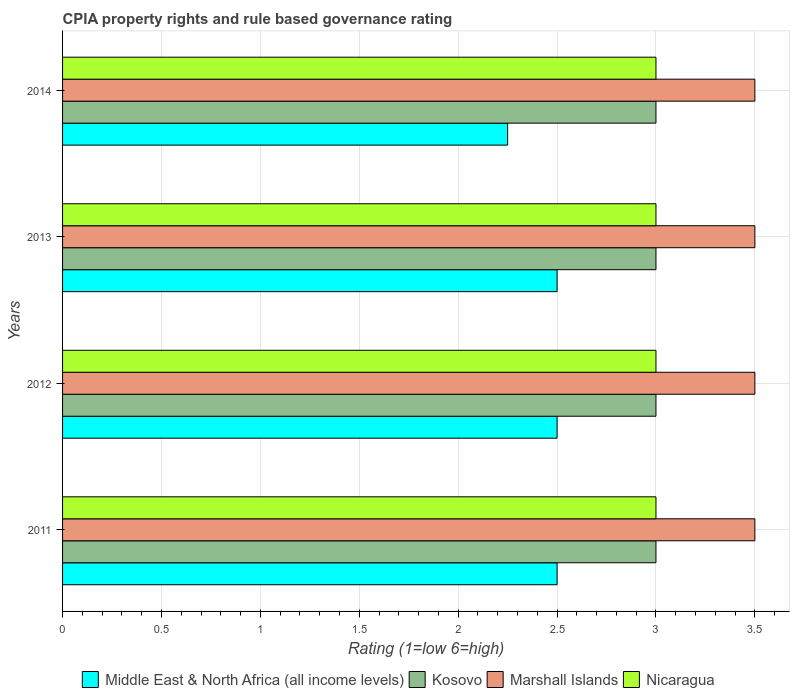How many bars are there on the 3rd tick from the bottom?
Provide a short and direct response. 4. What is the label of the 4th group of bars from the top?
Provide a succinct answer. 2011. Across all years, what is the maximum CPIA rating in Nicaragua?
Provide a succinct answer. 3. Across all years, what is the minimum CPIA rating in Kosovo?
Offer a terse response. 3. In which year was the CPIA rating in Nicaragua maximum?
Ensure brevity in your answer.  2011. In which year was the CPIA rating in Nicaragua minimum?
Offer a terse response. 2011. What is the total CPIA rating in Marshall Islands in the graph?
Give a very brief answer. 14. What is the difference between the CPIA rating in Nicaragua in 2012 and that in 2014?
Your answer should be very brief. 0. What is the average CPIA rating in Nicaragua per year?
Ensure brevity in your answer.  3. In the year 2012, what is the difference between the CPIA rating in Marshall Islands and CPIA rating in Nicaragua?
Provide a succinct answer. 0.5. What is the difference between the highest and the lowest CPIA rating in Nicaragua?
Provide a succinct answer. 0. Is the sum of the CPIA rating in Nicaragua in 2011 and 2012 greater than the maximum CPIA rating in Marshall Islands across all years?
Provide a short and direct response. Yes. Is it the case that in every year, the sum of the CPIA rating in Marshall Islands and CPIA rating in Middle East & North Africa (all income levels) is greater than the sum of CPIA rating in Nicaragua and CPIA rating in Kosovo?
Provide a succinct answer. No. What does the 4th bar from the top in 2013 represents?
Your answer should be very brief. Middle East & North Africa (all income levels). What does the 2nd bar from the bottom in 2011 represents?
Make the answer very short. Kosovo. Is it the case that in every year, the sum of the CPIA rating in Nicaragua and CPIA rating in Marshall Islands is greater than the CPIA rating in Middle East & North Africa (all income levels)?
Your answer should be very brief. Yes. What is the difference between two consecutive major ticks on the X-axis?
Give a very brief answer. 0.5. Are the values on the major ticks of X-axis written in scientific E-notation?
Your response must be concise. No. Does the graph contain any zero values?
Your answer should be very brief. No. How many legend labels are there?
Make the answer very short. 4. What is the title of the graph?
Keep it short and to the point. CPIA property rights and rule based governance rating. Does "Jordan" appear as one of the legend labels in the graph?
Your response must be concise. No. What is the Rating (1=low 6=high) of Middle East & North Africa (all income levels) in 2012?
Make the answer very short. 2.5. What is the Rating (1=low 6=high) in Kosovo in 2012?
Keep it short and to the point. 3. What is the Rating (1=low 6=high) of Nicaragua in 2013?
Keep it short and to the point. 3. What is the Rating (1=low 6=high) of Middle East & North Africa (all income levels) in 2014?
Give a very brief answer. 2.25. What is the Rating (1=low 6=high) of Kosovo in 2014?
Your response must be concise. 3. What is the Rating (1=low 6=high) in Marshall Islands in 2014?
Provide a succinct answer. 3.5. What is the Rating (1=low 6=high) of Nicaragua in 2014?
Your answer should be very brief. 3. Across all years, what is the maximum Rating (1=low 6=high) in Middle East & North Africa (all income levels)?
Offer a terse response. 2.5. Across all years, what is the maximum Rating (1=low 6=high) of Kosovo?
Keep it short and to the point. 3. Across all years, what is the maximum Rating (1=low 6=high) of Nicaragua?
Keep it short and to the point. 3. Across all years, what is the minimum Rating (1=low 6=high) in Middle East & North Africa (all income levels)?
Offer a terse response. 2.25. Across all years, what is the minimum Rating (1=low 6=high) of Kosovo?
Your response must be concise. 3. Across all years, what is the minimum Rating (1=low 6=high) in Marshall Islands?
Offer a very short reply. 3.5. Across all years, what is the minimum Rating (1=low 6=high) in Nicaragua?
Your answer should be compact. 3. What is the total Rating (1=low 6=high) of Middle East & North Africa (all income levels) in the graph?
Provide a succinct answer. 9.75. What is the total Rating (1=low 6=high) of Kosovo in the graph?
Give a very brief answer. 12. What is the total Rating (1=low 6=high) in Nicaragua in the graph?
Your answer should be compact. 12. What is the difference between the Rating (1=low 6=high) of Middle East & North Africa (all income levels) in 2011 and that in 2012?
Offer a terse response. 0. What is the difference between the Rating (1=low 6=high) of Kosovo in 2011 and that in 2012?
Your answer should be compact. 0. What is the difference between the Rating (1=low 6=high) in Middle East & North Africa (all income levels) in 2011 and that in 2013?
Keep it short and to the point. 0. What is the difference between the Rating (1=low 6=high) of Marshall Islands in 2011 and that in 2013?
Your answer should be compact. 0. What is the difference between the Rating (1=low 6=high) in Nicaragua in 2011 and that in 2013?
Ensure brevity in your answer.  0. What is the difference between the Rating (1=low 6=high) in Middle East & North Africa (all income levels) in 2011 and that in 2014?
Give a very brief answer. 0.25. What is the difference between the Rating (1=low 6=high) in Kosovo in 2011 and that in 2014?
Make the answer very short. 0. What is the difference between the Rating (1=low 6=high) in Nicaragua in 2011 and that in 2014?
Provide a succinct answer. 0. What is the difference between the Rating (1=low 6=high) in Nicaragua in 2012 and that in 2013?
Your answer should be compact. 0. What is the difference between the Rating (1=low 6=high) of Nicaragua in 2012 and that in 2014?
Your response must be concise. 0. What is the difference between the Rating (1=low 6=high) in Marshall Islands in 2013 and that in 2014?
Your answer should be compact. 0. What is the difference between the Rating (1=low 6=high) in Middle East & North Africa (all income levels) in 2011 and the Rating (1=low 6=high) in Kosovo in 2012?
Your response must be concise. -0.5. What is the difference between the Rating (1=low 6=high) of Kosovo in 2011 and the Rating (1=low 6=high) of Marshall Islands in 2013?
Provide a succinct answer. -0.5. What is the difference between the Rating (1=low 6=high) in Middle East & North Africa (all income levels) in 2011 and the Rating (1=low 6=high) in Kosovo in 2014?
Give a very brief answer. -0.5. What is the difference between the Rating (1=low 6=high) in Kosovo in 2011 and the Rating (1=low 6=high) in Marshall Islands in 2014?
Provide a succinct answer. -0.5. What is the difference between the Rating (1=low 6=high) in Kosovo in 2011 and the Rating (1=low 6=high) in Nicaragua in 2014?
Provide a short and direct response. 0. What is the difference between the Rating (1=low 6=high) in Middle East & North Africa (all income levels) in 2012 and the Rating (1=low 6=high) in Marshall Islands in 2013?
Offer a terse response. -1. What is the difference between the Rating (1=low 6=high) in Middle East & North Africa (all income levels) in 2012 and the Rating (1=low 6=high) in Nicaragua in 2013?
Give a very brief answer. -0.5. What is the difference between the Rating (1=low 6=high) in Kosovo in 2012 and the Rating (1=low 6=high) in Nicaragua in 2013?
Give a very brief answer. 0. What is the difference between the Rating (1=low 6=high) of Middle East & North Africa (all income levels) in 2012 and the Rating (1=low 6=high) of Kosovo in 2014?
Offer a terse response. -0.5. What is the difference between the Rating (1=low 6=high) of Kosovo in 2012 and the Rating (1=low 6=high) of Nicaragua in 2014?
Ensure brevity in your answer.  0. What is the difference between the Rating (1=low 6=high) of Middle East & North Africa (all income levels) in 2013 and the Rating (1=low 6=high) of Kosovo in 2014?
Offer a terse response. -0.5. What is the difference between the Rating (1=low 6=high) in Middle East & North Africa (all income levels) in 2013 and the Rating (1=low 6=high) in Marshall Islands in 2014?
Ensure brevity in your answer.  -1. What is the difference between the Rating (1=low 6=high) of Kosovo in 2013 and the Rating (1=low 6=high) of Nicaragua in 2014?
Give a very brief answer. 0. What is the average Rating (1=low 6=high) in Middle East & North Africa (all income levels) per year?
Provide a short and direct response. 2.44. What is the average Rating (1=low 6=high) in Marshall Islands per year?
Offer a terse response. 3.5. In the year 2011, what is the difference between the Rating (1=low 6=high) in Middle East & North Africa (all income levels) and Rating (1=low 6=high) in Kosovo?
Keep it short and to the point. -0.5. In the year 2011, what is the difference between the Rating (1=low 6=high) in Kosovo and Rating (1=low 6=high) in Marshall Islands?
Provide a succinct answer. -0.5. In the year 2012, what is the difference between the Rating (1=low 6=high) of Middle East & North Africa (all income levels) and Rating (1=low 6=high) of Marshall Islands?
Your answer should be compact. -1. In the year 2013, what is the difference between the Rating (1=low 6=high) in Middle East & North Africa (all income levels) and Rating (1=low 6=high) in Kosovo?
Give a very brief answer. -0.5. In the year 2013, what is the difference between the Rating (1=low 6=high) in Middle East & North Africa (all income levels) and Rating (1=low 6=high) in Marshall Islands?
Keep it short and to the point. -1. In the year 2013, what is the difference between the Rating (1=low 6=high) of Kosovo and Rating (1=low 6=high) of Nicaragua?
Your response must be concise. 0. In the year 2013, what is the difference between the Rating (1=low 6=high) of Marshall Islands and Rating (1=low 6=high) of Nicaragua?
Provide a succinct answer. 0.5. In the year 2014, what is the difference between the Rating (1=low 6=high) in Middle East & North Africa (all income levels) and Rating (1=low 6=high) in Kosovo?
Your response must be concise. -0.75. In the year 2014, what is the difference between the Rating (1=low 6=high) in Middle East & North Africa (all income levels) and Rating (1=low 6=high) in Marshall Islands?
Offer a terse response. -1.25. In the year 2014, what is the difference between the Rating (1=low 6=high) of Middle East & North Africa (all income levels) and Rating (1=low 6=high) of Nicaragua?
Provide a succinct answer. -0.75. In the year 2014, what is the difference between the Rating (1=low 6=high) of Kosovo and Rating (1=low 6=high) of Marshall Islands?
Give a very brief answer. -0.5. What is the ratio of the Rating (1=low 6=high) in Nicaragua in 2011 to that in 2012?
Give a very brief answer. 1. What is the ratio of the Rating (1=low 6=high) in Kosovo in 2011 to that in 2013?
Provide a short and direct response. 1. What is the ratio of the Rating (1=low 6=high) in Marshall Islands in 2011 to that in 2013?
Offer a very short reply. 1. What is the ratio of the Rating (1=low 6=high) of Nicaragua in 2011 to that in 2014?
Offer a very short reply. 1. What is the ratio of the Rating (1=low 6=high) of Nicaragua in 2012 to that in 2013?
Ensure brevity in your answer.  1. What is the ratio of the Rating (1=low 6=high) of Nicaragua in 2012 to that in 2014?
Provide a succinct answer. 1. What is the ratio of the Rating (1=low 6=high) in Kosovo in 2013 to that in 2014?
Make the answer very short. 1. What is the ratio of the Rating (1=low 6=high) of Marshall Islands in 2013 to that in 2014?
Offer a terse response. 1. What is the ratio of the Rating (1=low 6=high) of Nicaragua in 2013 to that in 2014?
Ensure brevity in your answer.  1. What is the difference between the highest and the second highest Rating (1=low 6=high) of Marshall Islands?
Offer a very short reply. 0. What is the difference between the highest and the second highest Rating (1=low 6=high) in Nicaragua?
Ensure brevity in your answer.  0. What is the difference between the highest and the lowest Rating (1=low 6=high) in Middle East & North Africa (all income levels)?
Your answer should be very brief. 0.25. What is the difference between the highest and the lowest Rating (1=low 6=high) of Kosovo?
Your response must be concise. 0. What is the difference between the highest and the lowest Rating (1=low 6=high) in Marshall Islands?
Ensure brevity in your answer.  0. 